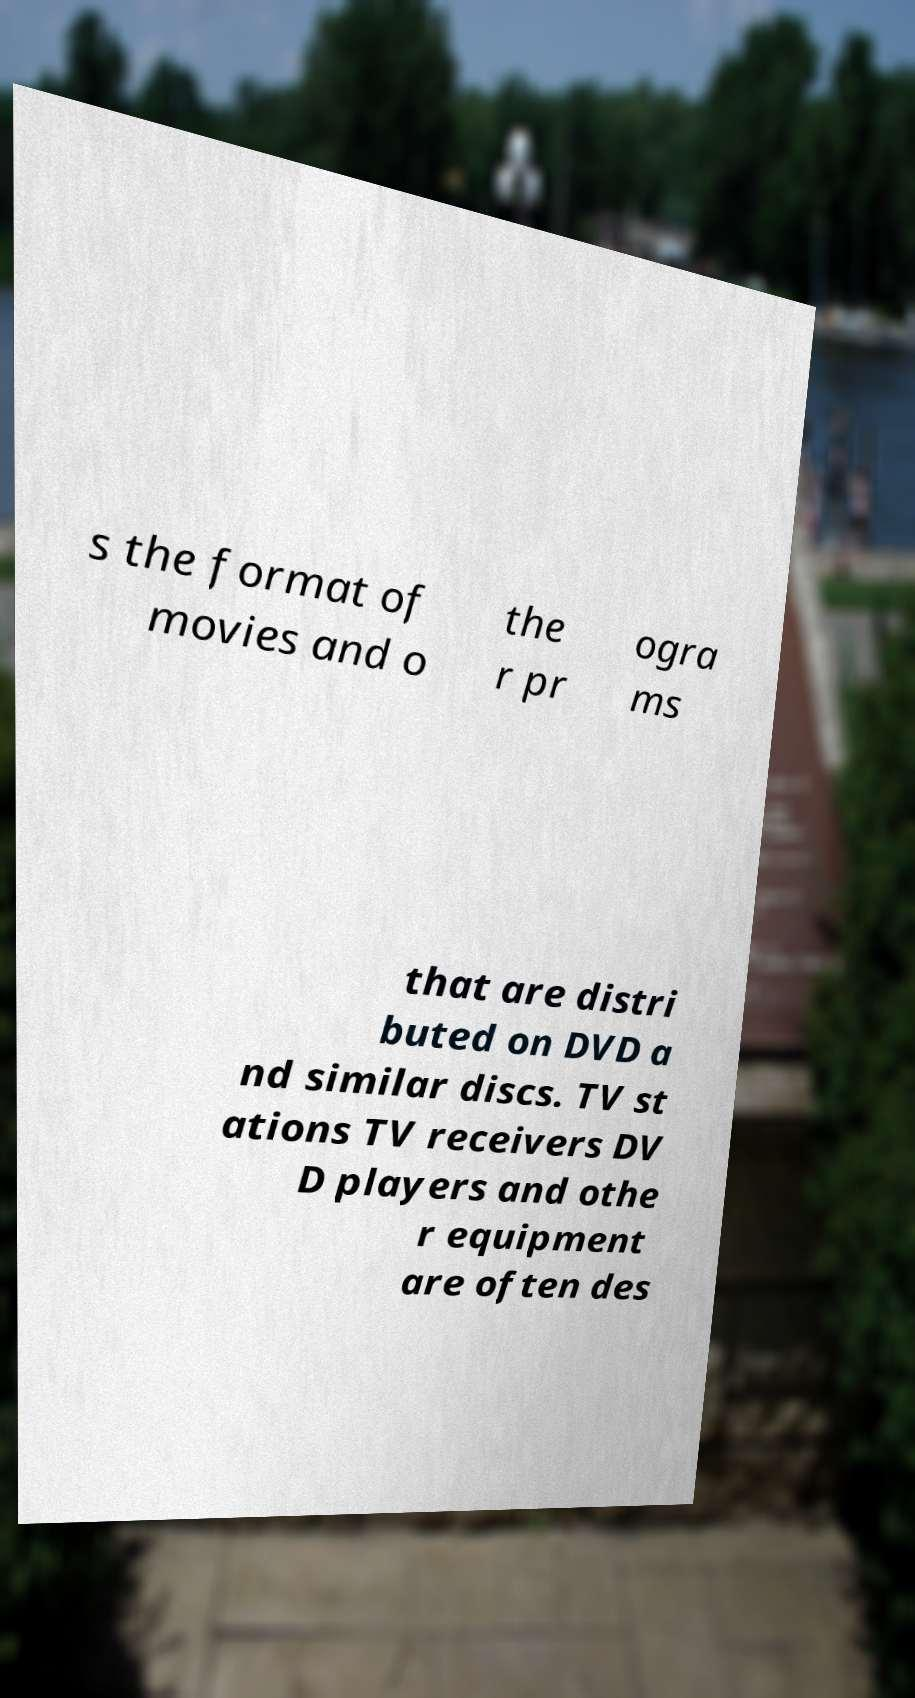For documentation purposes, I need the text within this image transcribed. Could you provide that? s the format of movies and o the r pr ogra ms that are distri buted on DVD a nd similar discs. TV st ations TV receivers DV D players and othe r equipment are often des 